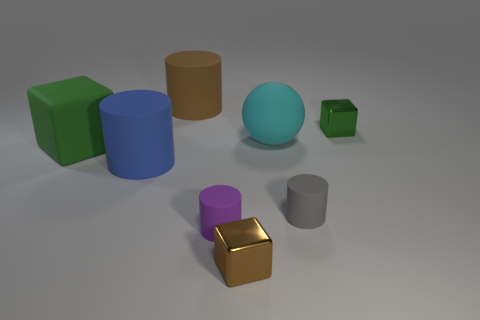What is the size of the other block that is the same color as the matte cube?
Give a very brief answer. Small. There is another metallic thing that is the same size as the green shiny thing; what is its color?
Ensure brevity in your answer.  Brown. What number of gray rubber objects are the same shape as the small green thing?
Your answer should be very brief. 0. What color is the block that is to the left of the brown cube?
Make the answer very short. Green. What number of rubber things are either small cylinders or small blue things?
Give a very brief answer. 2. What shape is the metallic object that is the same color as the big cube?
Offer a very short reply. Cube. How many other matte spheres have the same size as the rubber sphere?
Keep it short and to the point. 0. What color is the block that is both behind the blue thing and to the right of the large brown cylinder?
Offer a very short reply. Green. What number of things are either tiny green things or green objects?
Give a very brief answer. 2. How many tiny objects are cyan objects or purple balls?
Your answer should be very brief. 0. 